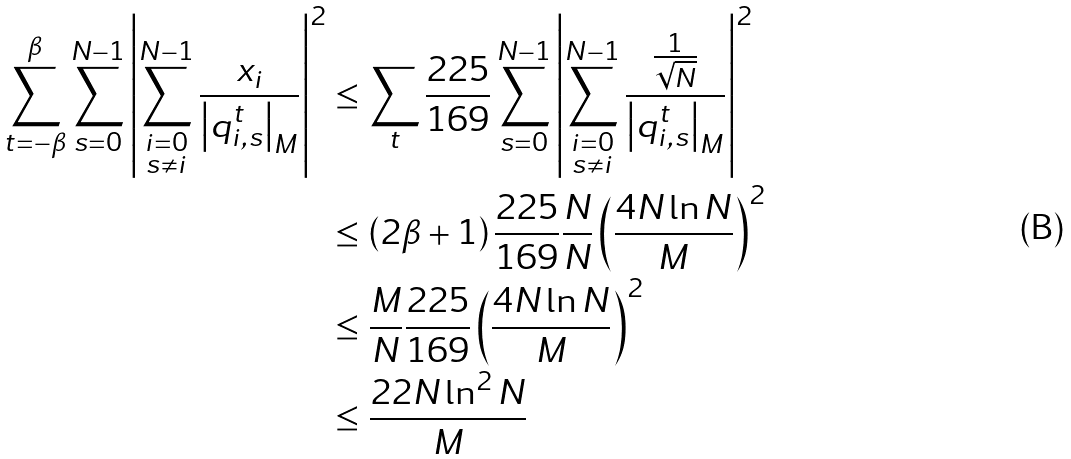<formula> <loc_0><loc_0><loc_500><loc_500>\sum _ { t = - \beta } ^ { \beta } \sum _ { s = 0 } ^ { N - 1 } \left | \sum _ { \substack { i = 0 \\ s \neq i } } ^ { N - 1 } \frac { x _ { i } } { \left | q _ { i , s } ^ { t } \right | _ { M } } \right | ^ { 2 } & \leq \sum _ { t } \frac { 2 2 5 } { 1 6 9 } \sum _ { s = 0 } ^ { N - 1 } \left | \sum _ { \substack { i = 0 \\ s \neq i } } ^ { N - 1 } \frac { \frac { 1 } { \sqrt { N } } } { \left | q _ { i , s } ^ { t } \right | _ { M } } \right | ^ { 2 } \\ & \leq \left ( 2 \beta + 1 \right ) \frac { 2 2 5 } { 1 6 9 } \frac { N } { N } \left ( \frac { 4 N \ln N } { M } \right ) ^ { 2 } \\ & \leq \frac { M } { N } \frac { 2 2 5 } { 1 6 9 } \left ( \frac { 4 N \ln N } { M } \right ) ^ { 2 } \\ & \leq \frac { 2 2 N \ln ^ { 2 } N } { M }</formula> 